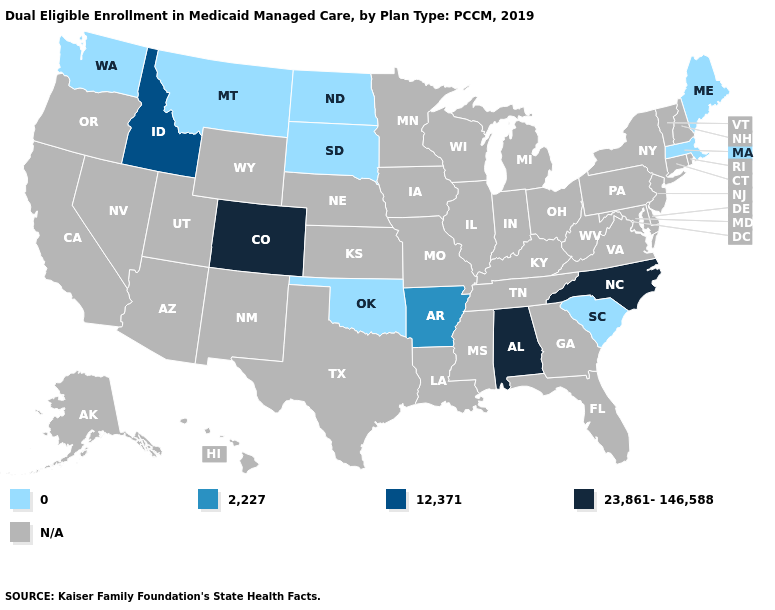Which states hav the highest value in the MidWest?
Keep it brief. North Dakota, South Dakota. What is the lowest value in the South?
Quick response, please. 0. What is the value of New York?
Short answer required. N/A. Does Arkansas have the lowest value in the USA?
Quick response, please. No. Among the states that border Connecticut , which have the lowest value?
Be succinct. Massachusetts. Which states have the highest value in the USA?
Quick response, please. Alabama, Colorado, North Carolina. What is the value of Oregon?
Write a very short answer. N/A. What is the lowest value in states that border South Dakota?
Short answer required. 0. Name the states that have a value in the range 0?
Write a very short answer. Maine, Massachusetts, Montana, North Dakota, Oklahoma, South Carolina, South Dakota, Washington. Which states have the highest value in the USA?
Keep it brief. Alabama, Colorado, North Carolina. What is the value of Ohio?
Concise answer only. N/A. What is the value of Texas?
Concise answer only. N/A. Which states have the lowest value in the USA?
Keep it brief. Maine, Massachusetts, Montana, North Dakota, Oklahoma, South Carolina, South Dakota, Washington. Which states have the lowest value in the USA?
Write a very short answer. Maine, Massachusetts, Montana, North Dakota, Oklahoma, South Carolina, South Dakota, Washington. 